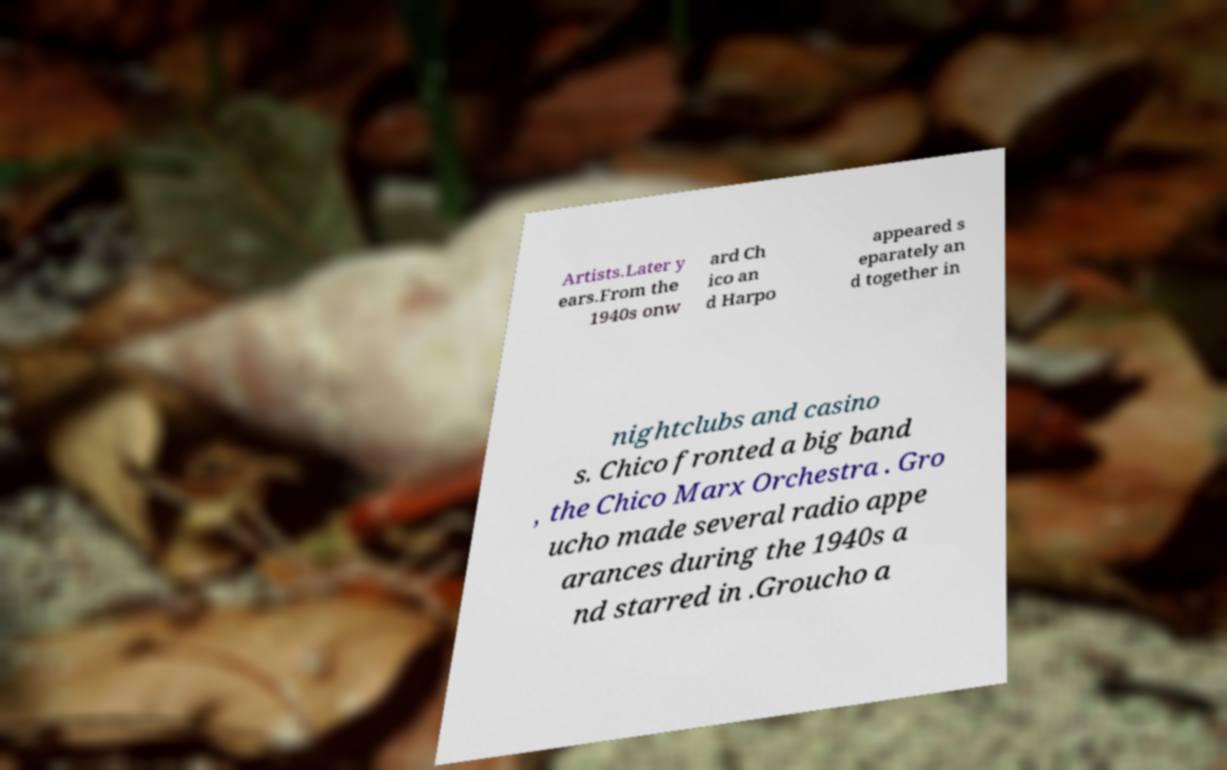Please read and relay the text visible in this image. What does it say? The text in the image appears to discuss the later years of certain artists, likely entertainers, starting from the 1940s. It mentions that individuals named Chico and Harpo appeared separately and together in nightclubs and casinos, with Chico leading a big band called the Chico Marx Orchestra. It also refers to someone named Groucho who made radio appearances during the 1940s and may have starred in an unspecified medium. Unfortunately, the text is incomplete due to the edges being cut off, so the full context and details cannot be determined from this image alone. 